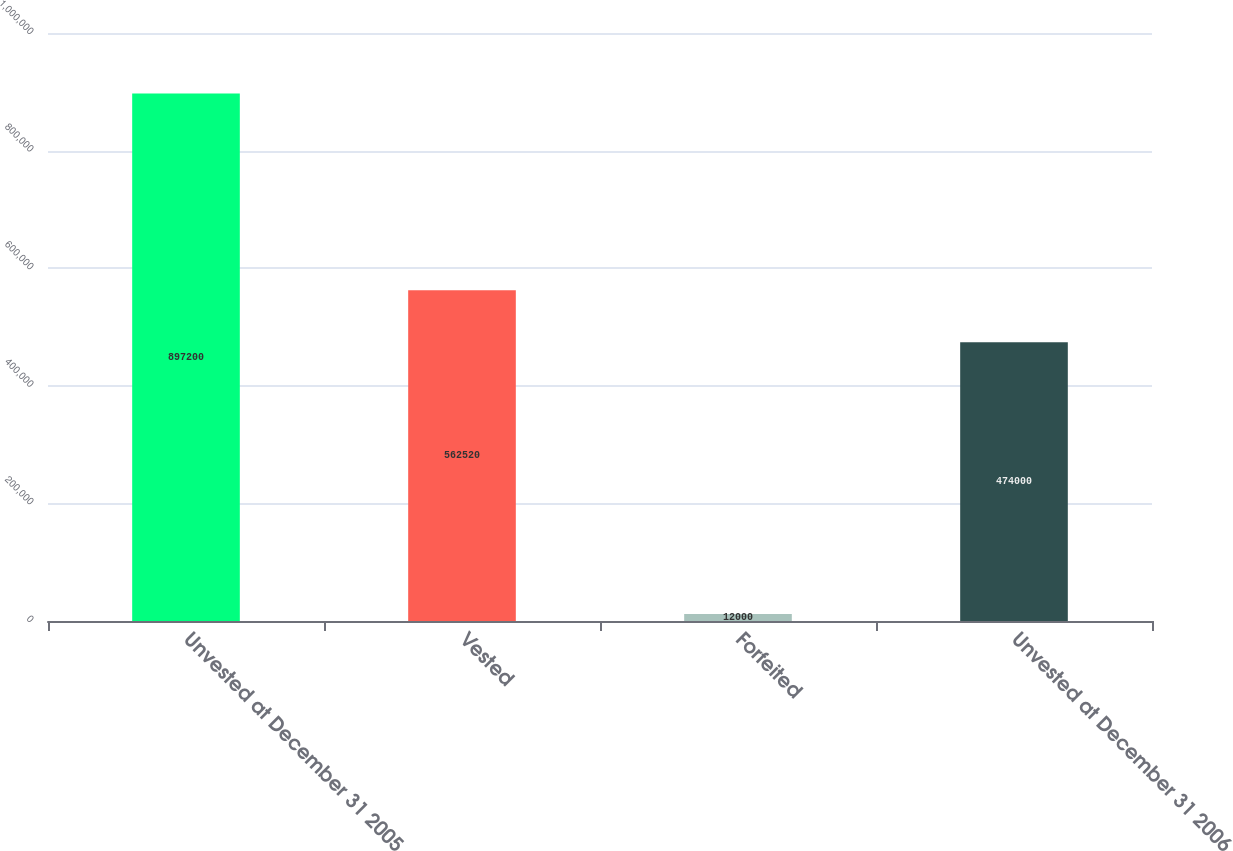Convert chart. <chart><loc_0><loc_0><loc_500><loc_500><bar_chart><fcel>Unvested at December 31 2005<fcel>Vested<fcel>Forfeited<fcel>Unvested at December 31 2006<nl><fcel>897200<fcel>562520<fcel>12000<fcel>474000<nl></chart> 